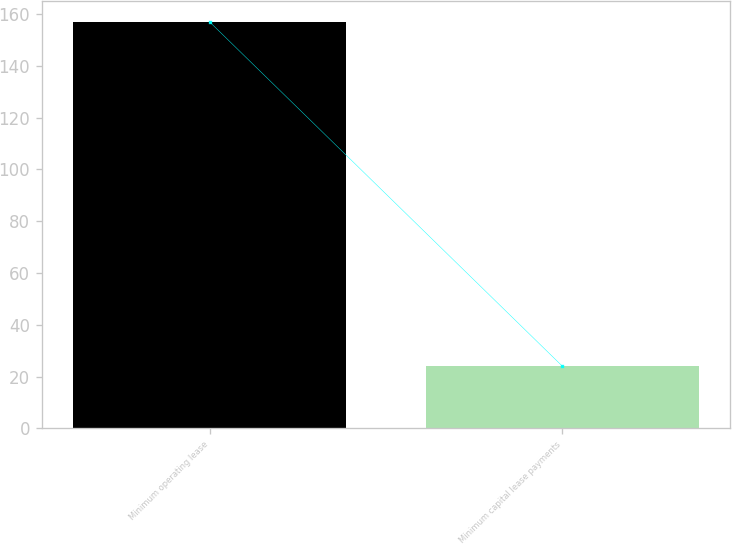Convert chart to OTSL. <chart><loc_0><loc_0><loc_500><loc_500><bar_chart><fcel>Minimum operating lease<fcel>Minimum capital lease payments<nl><fcel>157<fcel>24<nl></chart> 